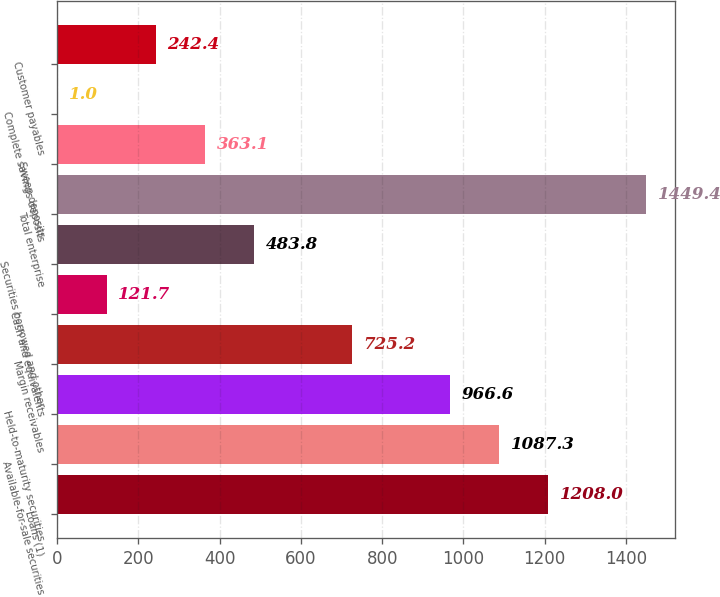<chart> <loc_0><loc_0><loc_500><loc_500><bar_chart><fcel>Loans (1)<fcel>Available-for-sale securities<fcel>Held-to-maturity securities<fcel>Margin receivables<fcel>Cash and equivalents<fcel>Securities borrowed and other<fcel>Total enterprise<fcel>Sweep deposits<fcel>Complete savings deposits<fcel>Customer payables<nl><fcel>1208<fcel>1087.3<fcel>966.6<fcel>725.2<fcel>121.7<fcel>483.8<fcel>1449.4<fcel>363.1<fcel>1<fcel>242.4<nl></chart> 